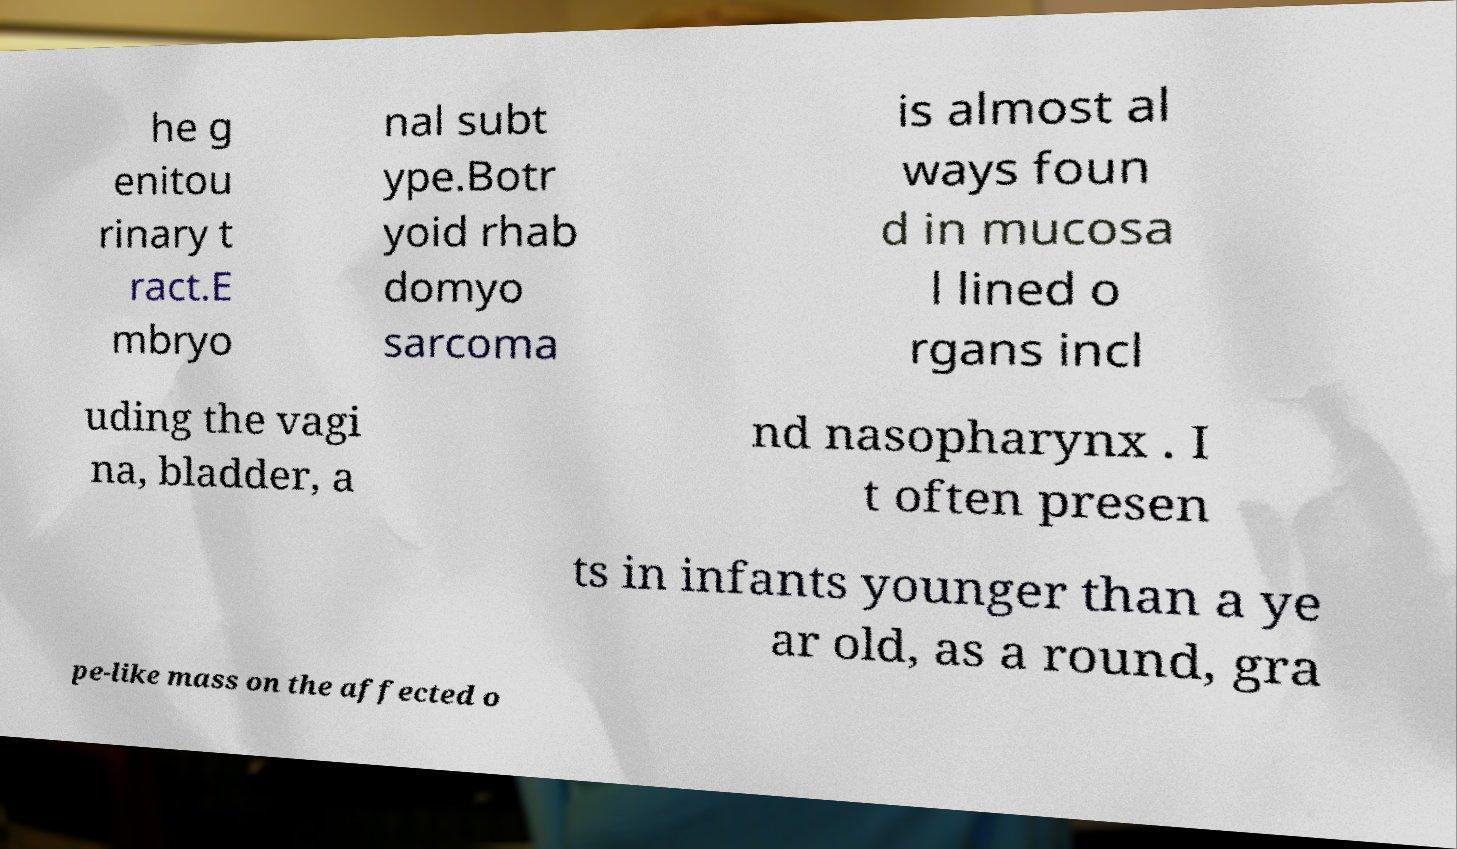Can you accurately transcribe the text from the provided image for me? he g enitou rinary t ract.E mbryo nal subt ype.Botr yoid rhab domyo sarcoma is almost al ways foun d in mucosa l lined o rgans incl uding the vagi na, bladder, a nd nasopharynx . I t often presen ts in infants younger than a ye ar old, as a round, gra pe-like mass on the affected o 